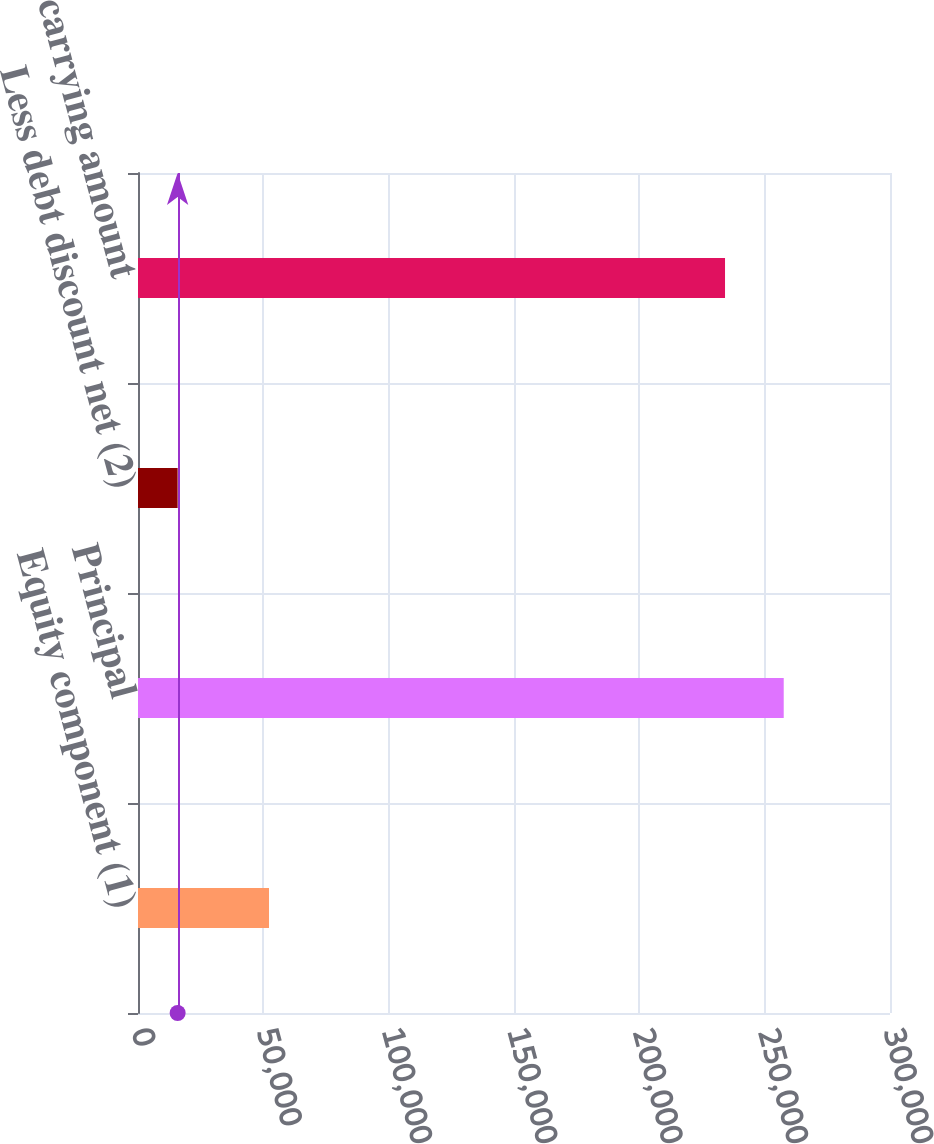<chart> <loc_0><loc_0><loc_500><loc_500><bar_chart><fcel>Equity component (1)<fcel>Principal<fcel>Less debt discount net (2)<fcel>Net carrying amount<nl><fcel>52263<fcel>257604<fcel>15815<fcel>234185<nl></chart> 